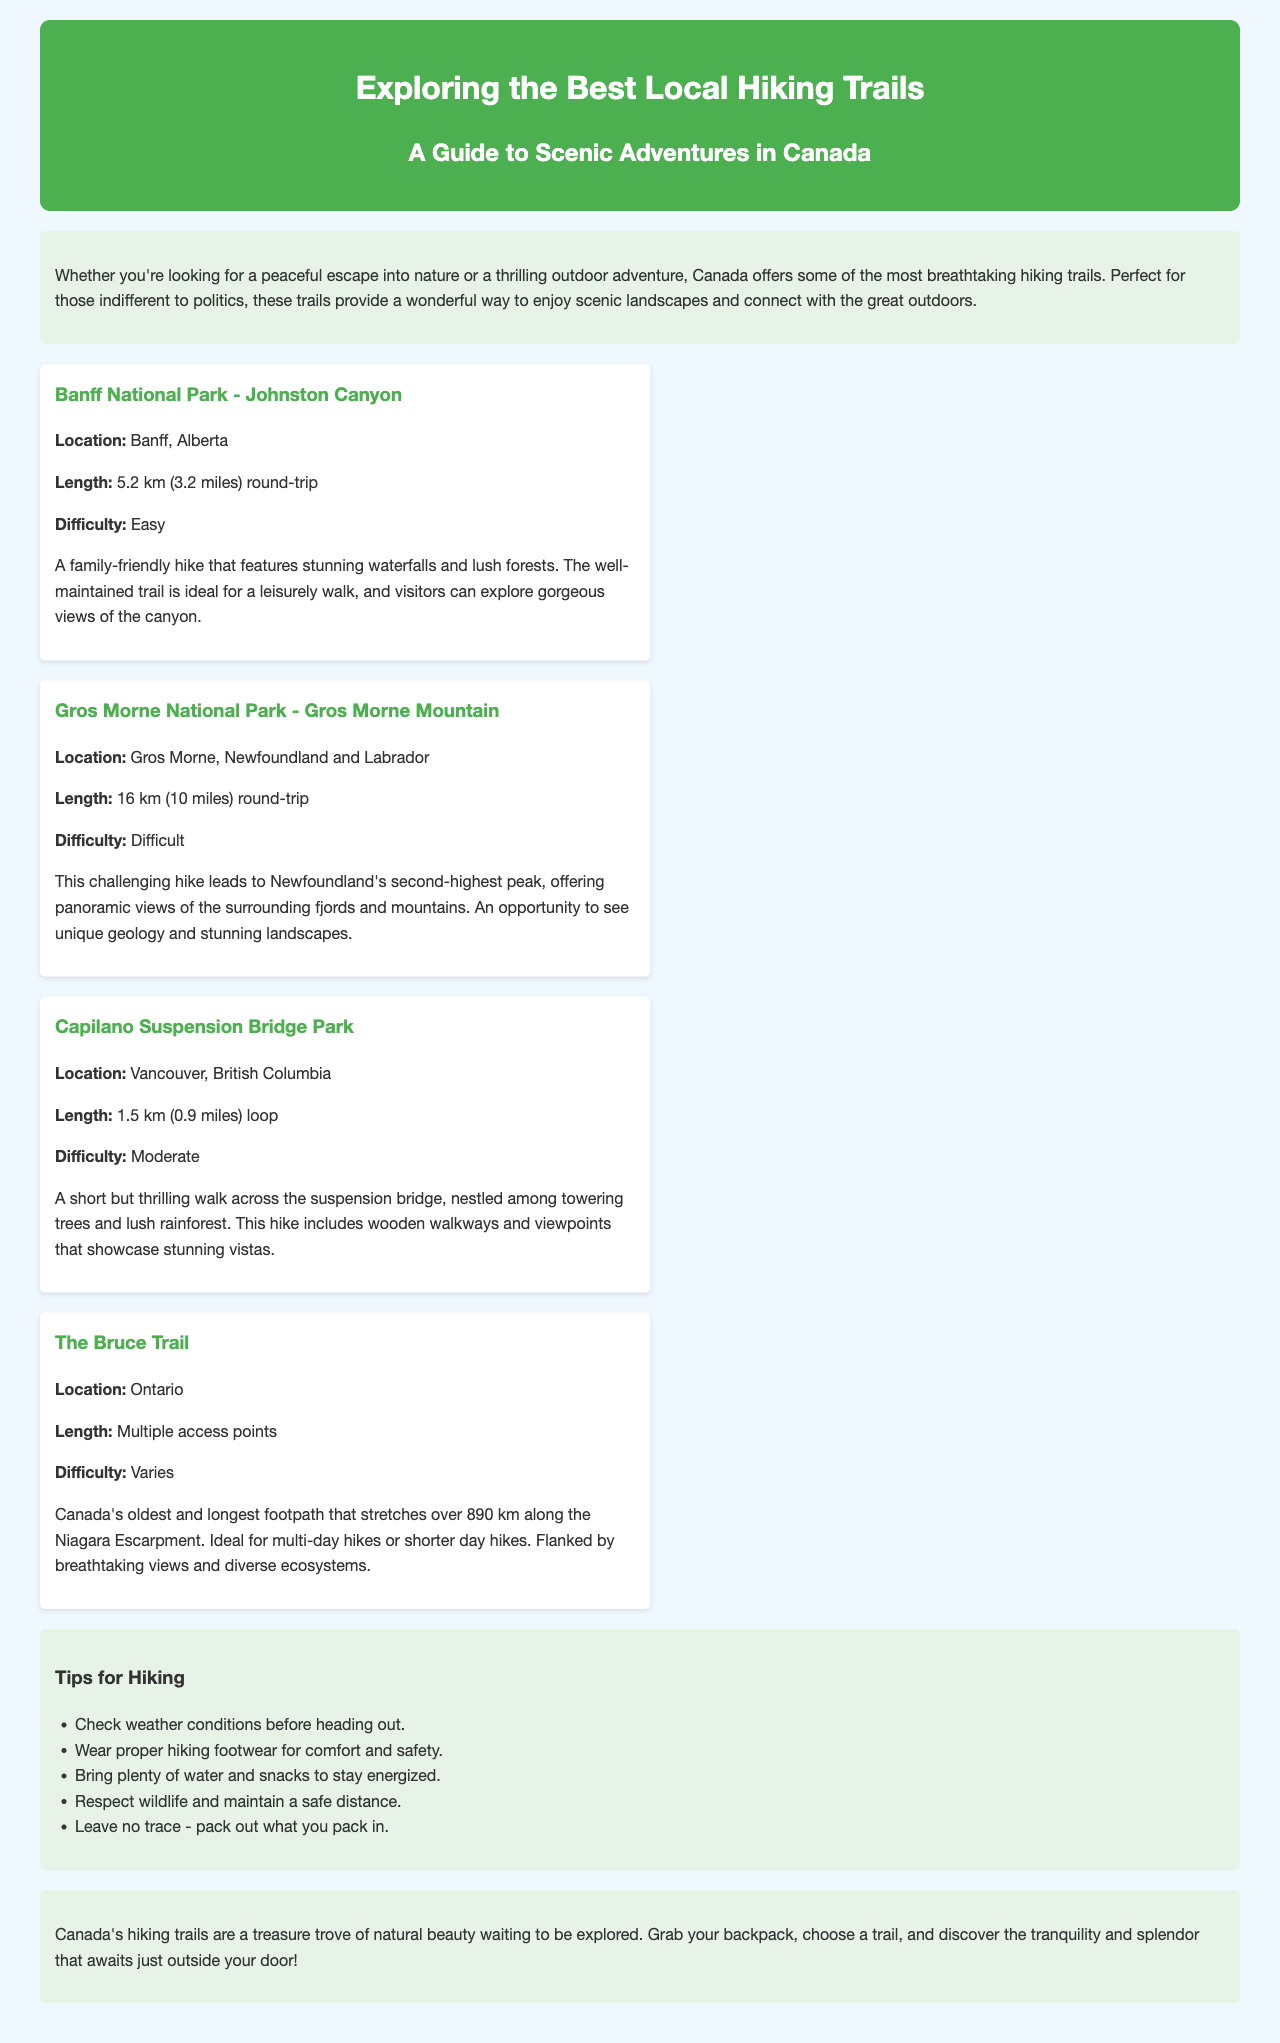what is the title of the brochure? The title is prominently displayed at the top of the document and specifically says the intended focus of the brochure.
Answer: Exploring the Best Local Hiking Trails what is the location of Johnston Canyon? Johnston Canyon is mentioned as a specific trail in the document with its location provided in the details.
Answer: Banff, Alberta what is the length of the Gros Morne Mountain hike? The document provides specific lengths for each trail listed, which includes Gros Morne Mountain.
Answer: 16 km (10 miles) round-trip what is the difficulty level of the Capilano Suspension Bridge Park hike? Each trail in the brochure includes a difficulty rating, which is also noted for Capilano Suspension Bridge Park.
Answer: Moderate how many kilometers does The Bruce Trail stretch? The length is specified in the section about The Bruce Trail, highlighting its notable feature as the longest footpath in Canada.
Answer: over 890 km why is the Johnston Canyon hike considered family-friendly? The description of the Johnston Canyon hike includes adjectives that imply accessibility and ease, which makes it suitable for families.
Answer: features stunning waterfalls and lush forests what kind of footwear is recommended for hiking? The tips provided in the document include advice on appropriate hiking gear for safety and comfort, specifically mentioning footwear.
Answer: proper hiking footwear what is the primary focus of the brochure? The introductory section provides a clear idea of the brochure's main theme and purpose.
Answer: scenic landscapes and connect with the great outdoors which province is Gros Morne National Park located in? The document explicitly states the province associated with Gros Morne National Park.
Answer: Newfoundland and Labrador 